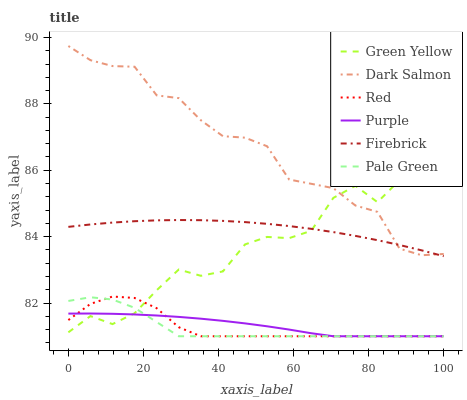Does Pale Green have the minimum area under the curve?
Answer yes or no. Yes. Does Dark Salmon have the maximum area under the curve?
Answer yes or no. Yes. Does Firebrick have the minimum area under the curve?
Answer yes or no. No. Does Firebrick have the maximum area under the curve?
Answer yes or no. No. Is Purple the smoothest?
Answer yes or no. Yes. Is Green Yellow the roughest?
Answer yes or no. Yes. Is Firebrick the smoothest?
Answer yes or no. No. Is Firebrick the roughest?
Answer yes or no. No. Does Purple have the lowest value?
Answer yes or no. Yes. Does Firebrick have the lowest value?
Answer yes or no. No. Does Dark Salmon have the highest value?
Answer yes or no. Yes. Does Firebrick have the highest value?
Answer yes or no. No. Is Red less than Dark Salmon?
Answer yes or no. Yes. Is Dark Salmon greater than Pale Green?
Answer yes or no. Yes. Does Green Yellow intersect Red?
Answer yes or no. Yes. Is Green Yellow less than Red?
Answer yes or no. No. Is Green Yellow greater than Red?
Answer yes or no. No. Does Red intersect Dark Salmon?
Answer yes or no. No. 